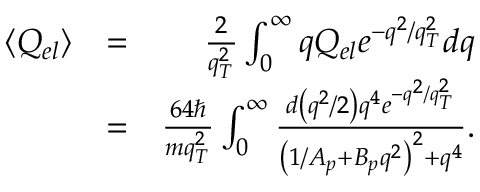<formula> <loc_0><loc_0><loc_500><loc_500>\begin{array} { r l r } { \langle Q _ { e l } \rangle } & { = } & { \frac { 2 } { q _ { T } ^ { 2 } } \int _ { 0 } ^ { \infty } q Q _ { e l } e ^ { - q ^ { 2 } / q _ { T } ^ { 2 } } d q } \\ & { = } & { \frac { 6 4 } { m q _ { T } ^ { 2 } } \int _ { 0 } ^ { \infty } \frac { { d } \left ( q ^ { 2 } / 2 \right ) q ^ { 4 } e ^ { - q ^ { 2 } / q _ { T } ^ { 2 } } } { { \left ( 1 / A _ { p } + B _ { p } q ^ { 2 } \right ) ^ { 2 } } + q ^ { 4 } } . } \end{array}</formula> 